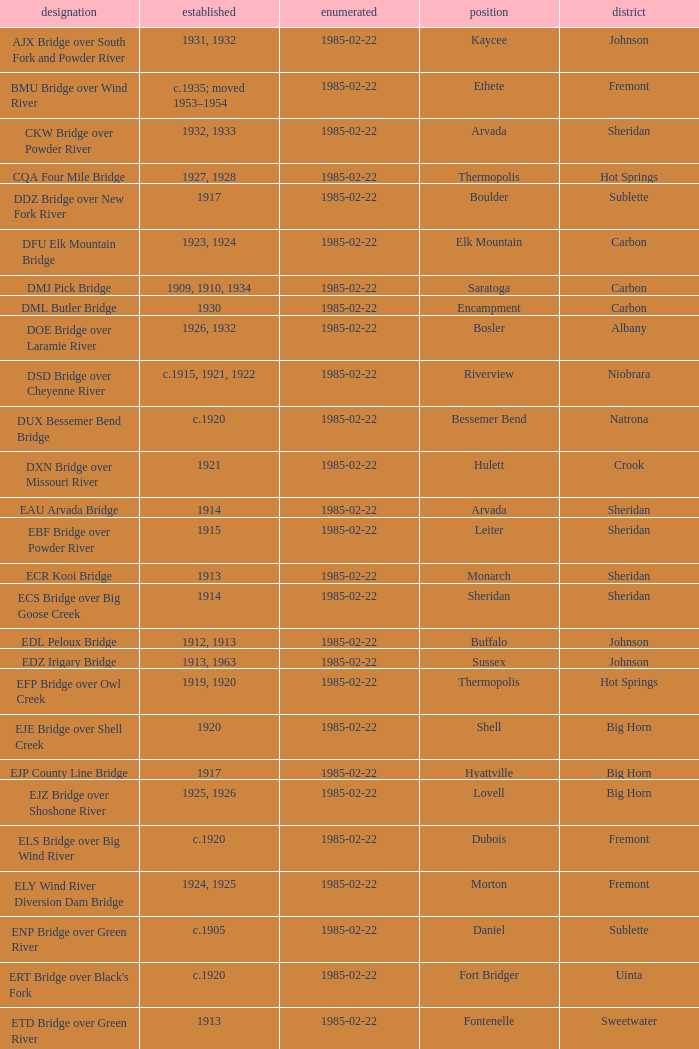What bridge in Sheridan county was built in 1915? EBF Bridge over Powder River. 